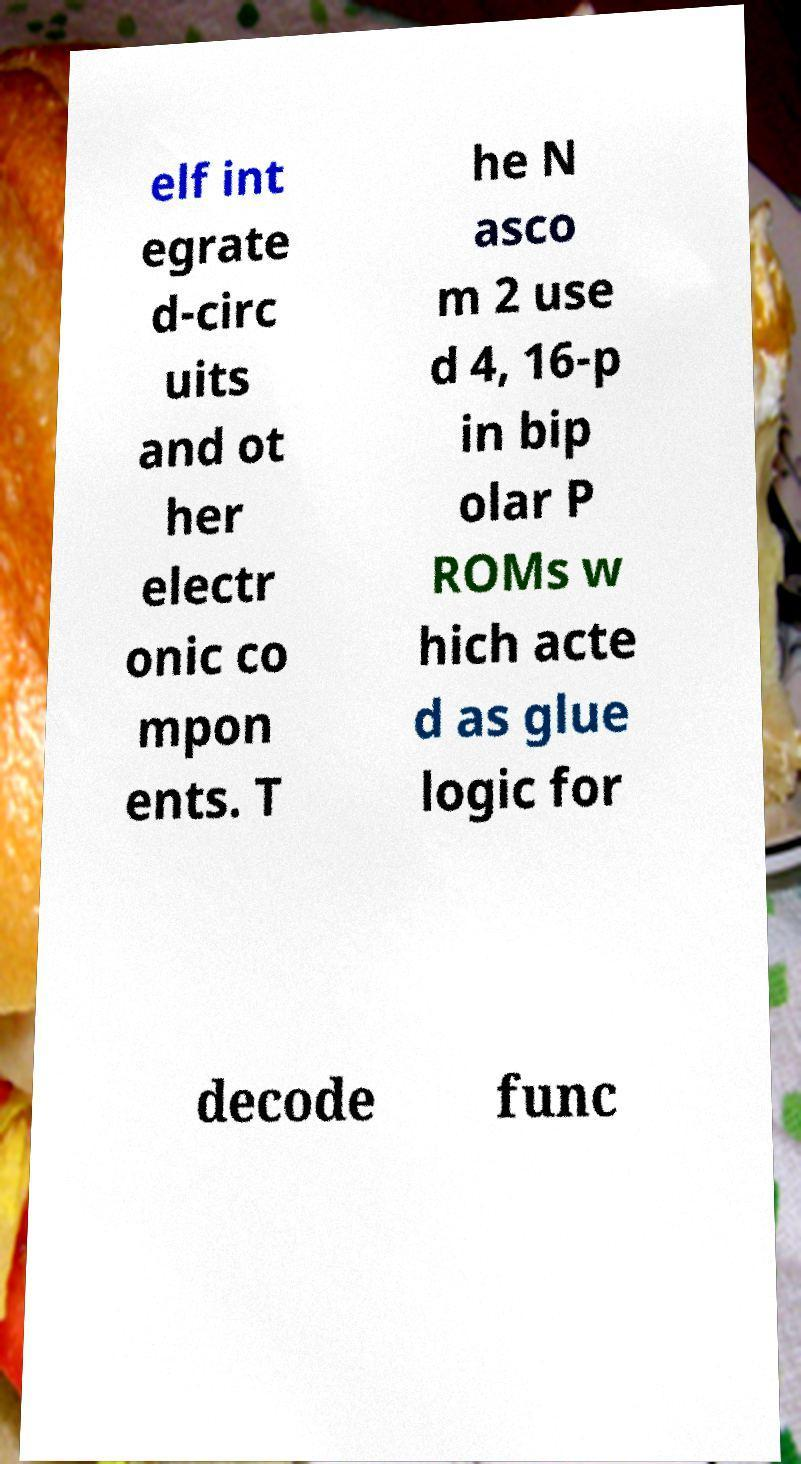Please identify and transcribe the text found in this image. elf int egrate d-circ uits and ot her electr onic co mpon ents. T he N asco m 2 use d 4, 16-p in bip olar P ROMs w hich acte d as glue logic for decode func 